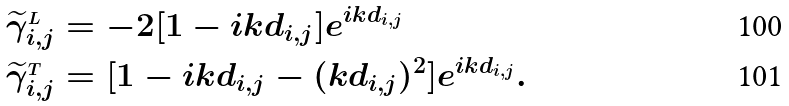Convert formula to latex. <formula><loc_0><loc_0><loc_500><loc_500>& \widetilde { \gamma } ^ { _ { L } } _ { i , j } = - 2 [ 1 - i k d _ { i , j } ] e ^ { i k d _ { i , j } } \\ & \widetilde { \gamma } ^ { _ { T } } _ { i , j } = [ 1 - i k d _ { i , j } - ( k d _ { i , j } ) ^ { 2 } ] e ^ { i k d _ { i , j } } .</formula> 